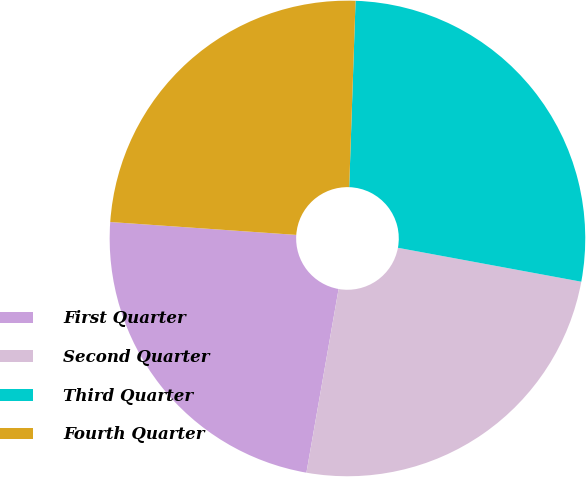Convert chart. <chart><loc_0><loc_0><loc_500><loc_500><pie_chart><fcel>First Quarter<fcel>Second Quarter<fcel>Third Quarter<fcel>Fourth Quarter<nl><fcel>23.34%<fcel>24.85%<fcel>27.37%<fcel>24.44%<nl></chart> 